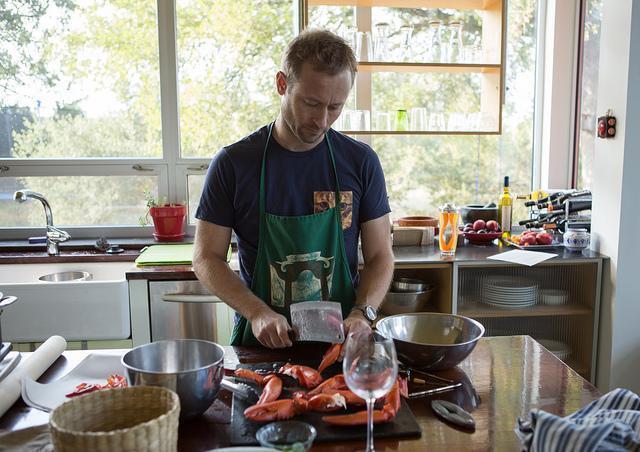What is the man in the apron cooking?
Indicate the correct response by choosing from the four available options to answer the question.
Options: Lobster, lamb, sausage, salmon. Lobster. 